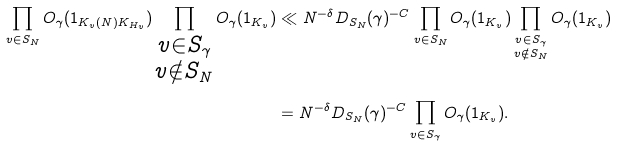<formula> <loc_0><loc_0><loc_500><loc_500>\prod _ { v \in S _ { N } } O _ { \gamma } ( { 1 } _ { K _ { v } ( N ) K _ { H _ { v } } } ) \prod _ { \substack { v \in S _ { \gamma } \\ v \notin S _ { N } } } O _ { \gamma } ( { 1 } _ { K _ { v } } ) & \ll N ^ { - \delta } D _ { S _ { N } } ( \gamma ) ^ { - C } \prod _ { v \in S _ { N } } O _ { \gamma } ( { 1 } _ { K _ { v } } ) \prod _ { \substack { v \in S _ { \gamma } \\ v \notin S _ { N } } } O _ { \gamma } ( { 1 } _ { K _ { v } } ) \\ & = N ^ { - \delta } D _ { S _ { N } } ( \gamma ) ^ { - C } \prod _ { v \in S _ { \gamma } } O _ { \gamma } ( { 1 } _ { K _ { v } } ) .</formula> 